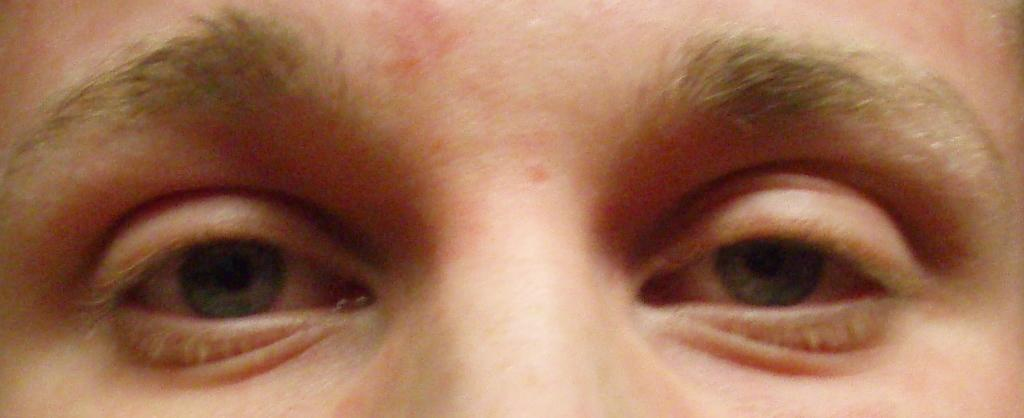What body part is depicted in the image? There are human eyes in the image. What features are visible around the eyes? Eyelashes and eyebrows are visible in the image. What type of plants can be seen growing near the eyes in the image? There are no plants present in the image; it only features human eyes, eyelashes, and eyebrows. 